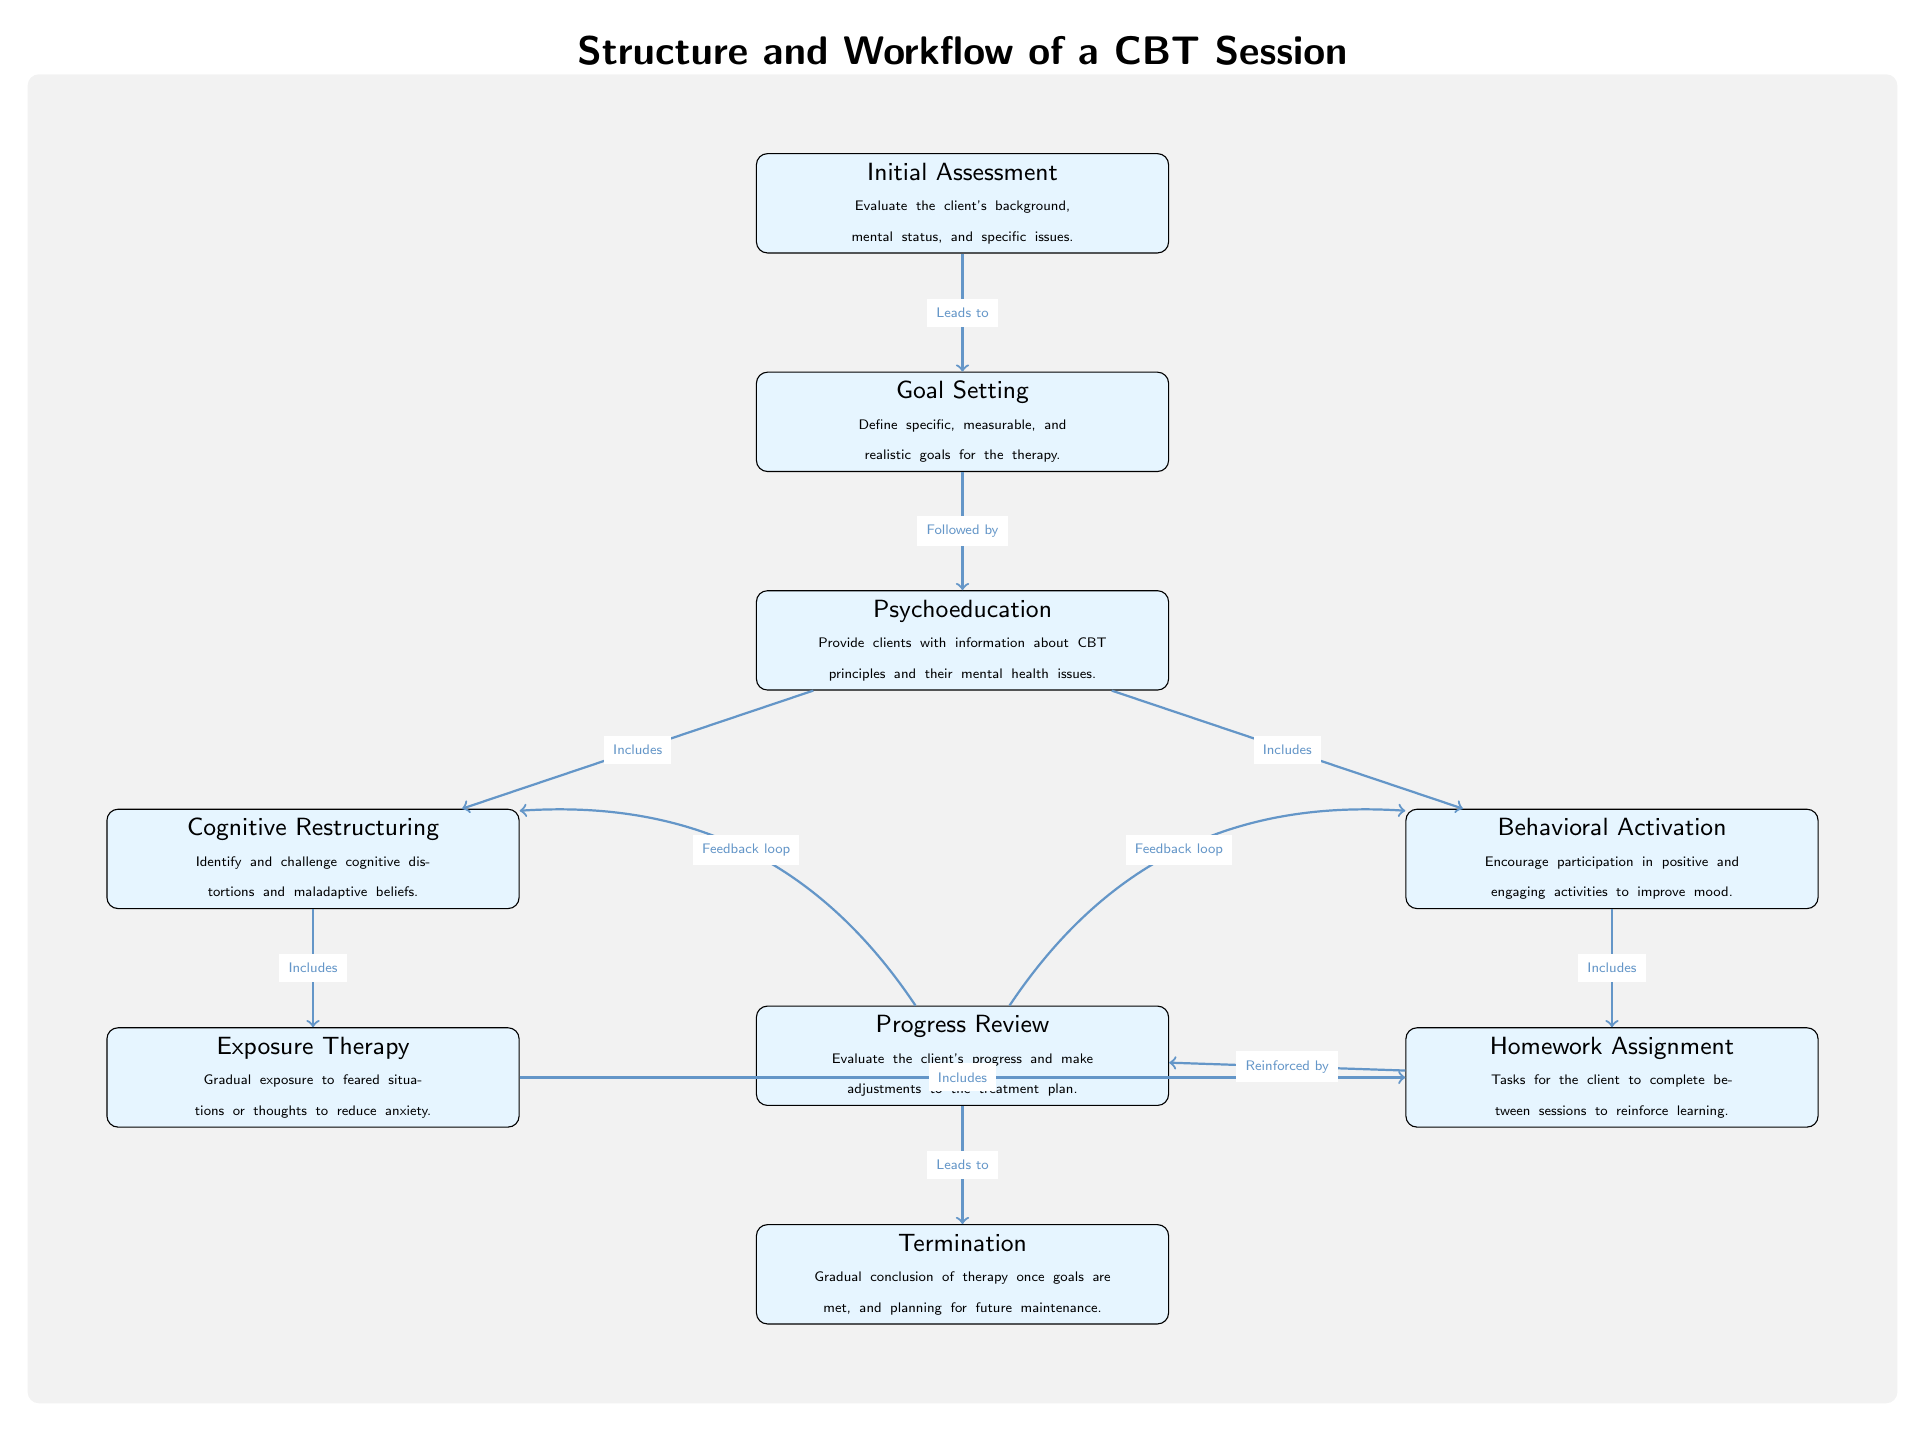What is the first step in a CBT session? The diagram indicates that the first step in a CBT session is the "Initial Assessment," where the therapist evaluates the client's background, mental status, and specific issues.
Answer: Initial Assessment How many main components are in the CBT session workflow? By counting the nodes in the diagram, there are a total of eight main components that outline the workflow of a CBT session.
Answer: Eight What is the last step before termination? According to the diagram, the last step before termination is the "Progress Review," where the client's progress is evaluated and adjustments to the treatment plan are made.
Answer: Progress Review Which two components provide feedback loops? The diagram shows that both "Cognitive Restructuring" and "Behavioral Activation" have feedback loops connected to the "Progress Review," indicating that progress in these areas may influence future sessions.
Answer: Cognitive Restructuring and Behavioral Activation What technique is involved in reducing anxiety? The diagram describes "Exposure Therapy" as the technique that involves gradual exposure to feared situations or thoughts to help clients reduce anxiety.
Answer: Exposure Therapy Which step directly follows goal setting? The flow of the diagram demonstrates that the step that directly follows "Goal Setting" is "Psychoeducation," where clients receive information about CBT principles and mental health issues.
Answer: Psychoeducation What are the two techniques included under psychoeducation? Examining the diagram, the two techniques included under "Psychoeducation" are "Cognitive Restructuring" and "Behavioral Activation."
Answer: Cognitive Restructuring and Behavioral Activation What task is assigned for completion between sessions? The "Homework Assignment" is identified in the diagram as the specific task that clients are assigned to complete between therapy sessions to reinforce what they've learned.
Answer: Homework Assignment What leads to termination in the diagram? The diagram indicates that the "Progress Review," following the client's assessment and adjustments, ultimately leads to "Termination" of therapy.
Answer: Progress Review 